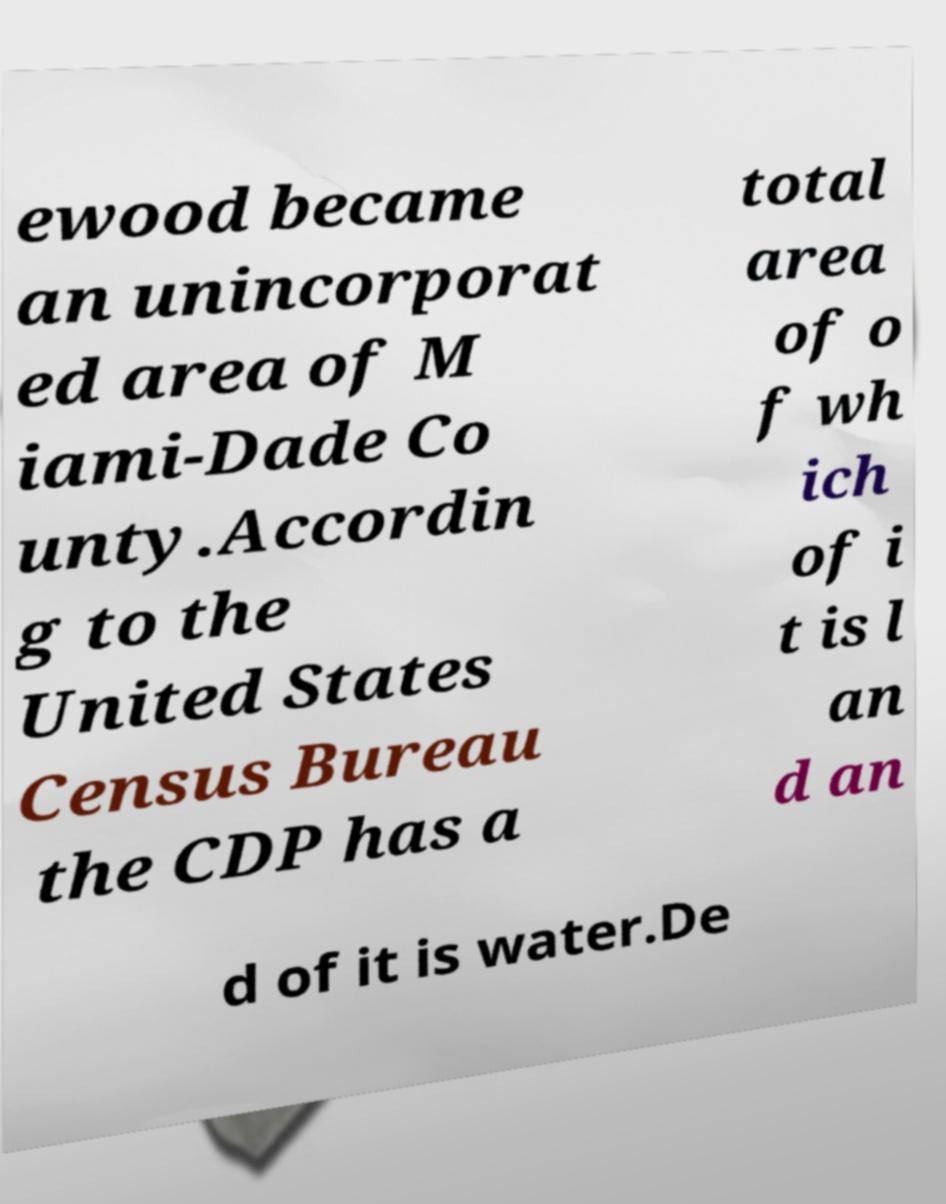Please identify and transcribe the text found in this image. ewood became an unincorporat ed area of M iami-Dade Co unty.Accordin g to the United States Census Bureau the CDP has a total area of o f wh ich of i t is l an d an d of it is water.De 